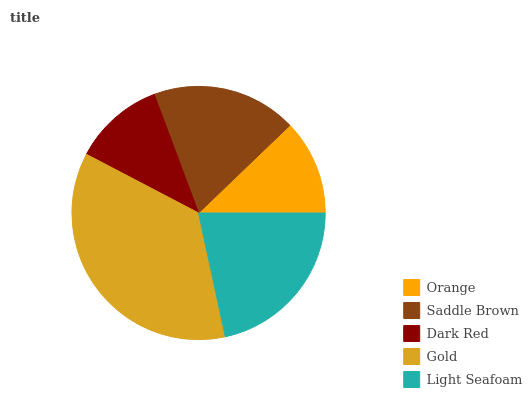Is Dark Red the minimum?
Answer yes or no. Yes. Is Gold the maximum?
Answer yes or no. Yes. Is Saddle Brown the minimum?
Answer yes or no. No. Is Saddle Brown the maximum?
Answer yes or no. No. Is Saddle Brown greater than Orange?
Answer yes or no. Yes. Is Orange less than Saddle Brown?
Answer yes or no. Yes. Is Orange greater than Saddle Brown?
Answer yes or no. No. Is Saddle Brown less than Orange?
Answer yes or no. No. Is Saddle Brown the high median?
Answer yes or no. Yes. Is Saddle Brown the low median?
Answer yes or no. Yes. Is Gold the high median?
Answer yes or no. No. Is Gold the low median?
Answer yes or no. No. 